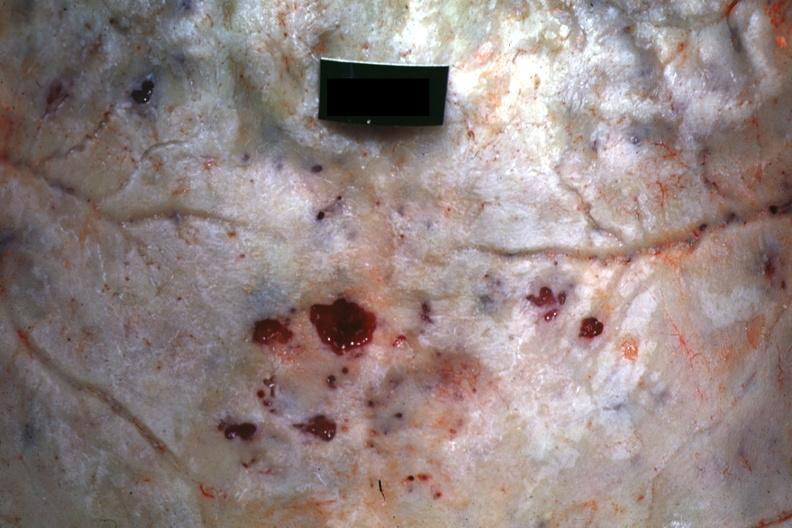does squamous cell carcinoma, lip remote, show close-up view of hemorrhagic excavation quite good?
Answer the question using a single word or phrase. No 